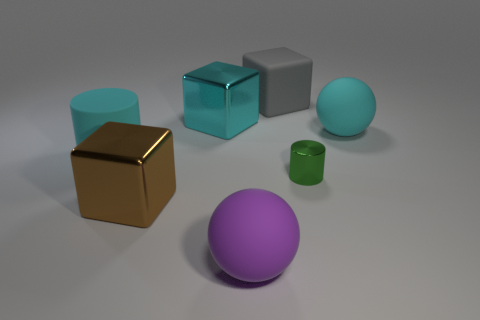Add 1 tiny blue metal spheres. How many objects exist? 8 Subtract 2 balls. How many balls are left? 0 Subtract all gray rubber blocks. How many blocks are left? 2 Subtract all balls. How many objects are left? 5 Subtract all cyan cubes. How many cubes are left? 2 Subtract 0 gray cylinders. How many objects are left? 7 Subtract all yellow cubes. Subtract all yellow balls. How many cubes are left? 3 Subtract all brown spheres. How many blue blocks are left? 0 Subtract all small brown matte cubes. Subtract all large purple rubber balls. How many objects are left? 6 Add 4 big gray matte cubes. How many big gray matte cubes are left? 5 